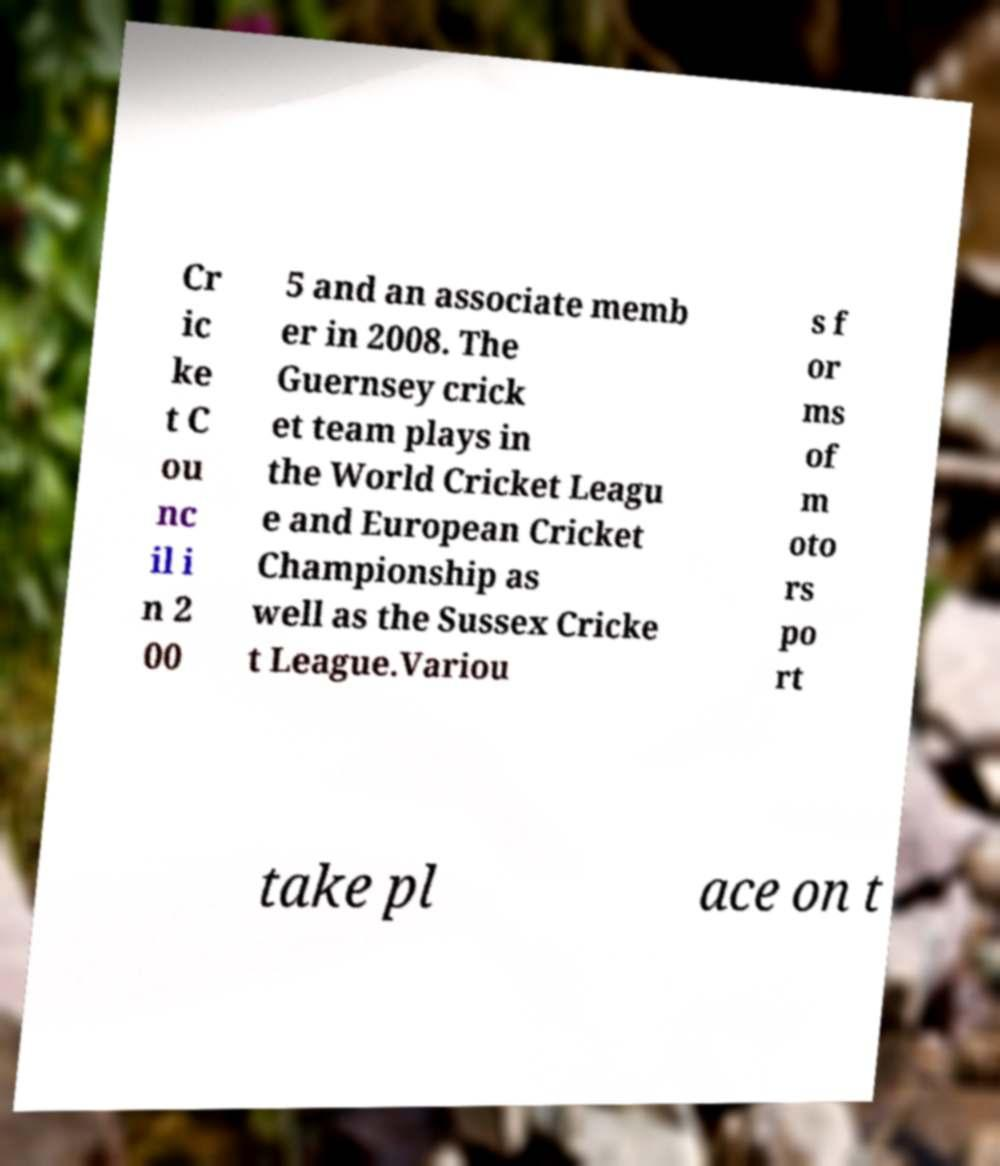Can you read and provide the text displayed in the image?This photo seems to have some interesting text. Can you extract and type it out for me? Cr ic ke t C ou nc il i n 2 00 5 and an associate memb er in 2008. The Guernsey crick et team plays in the World Cricket Leagu e and European Cricket Championship as well as the Sussex Cricke t League.Variou s f or ms of m oto rs po rt take pl ace on t 